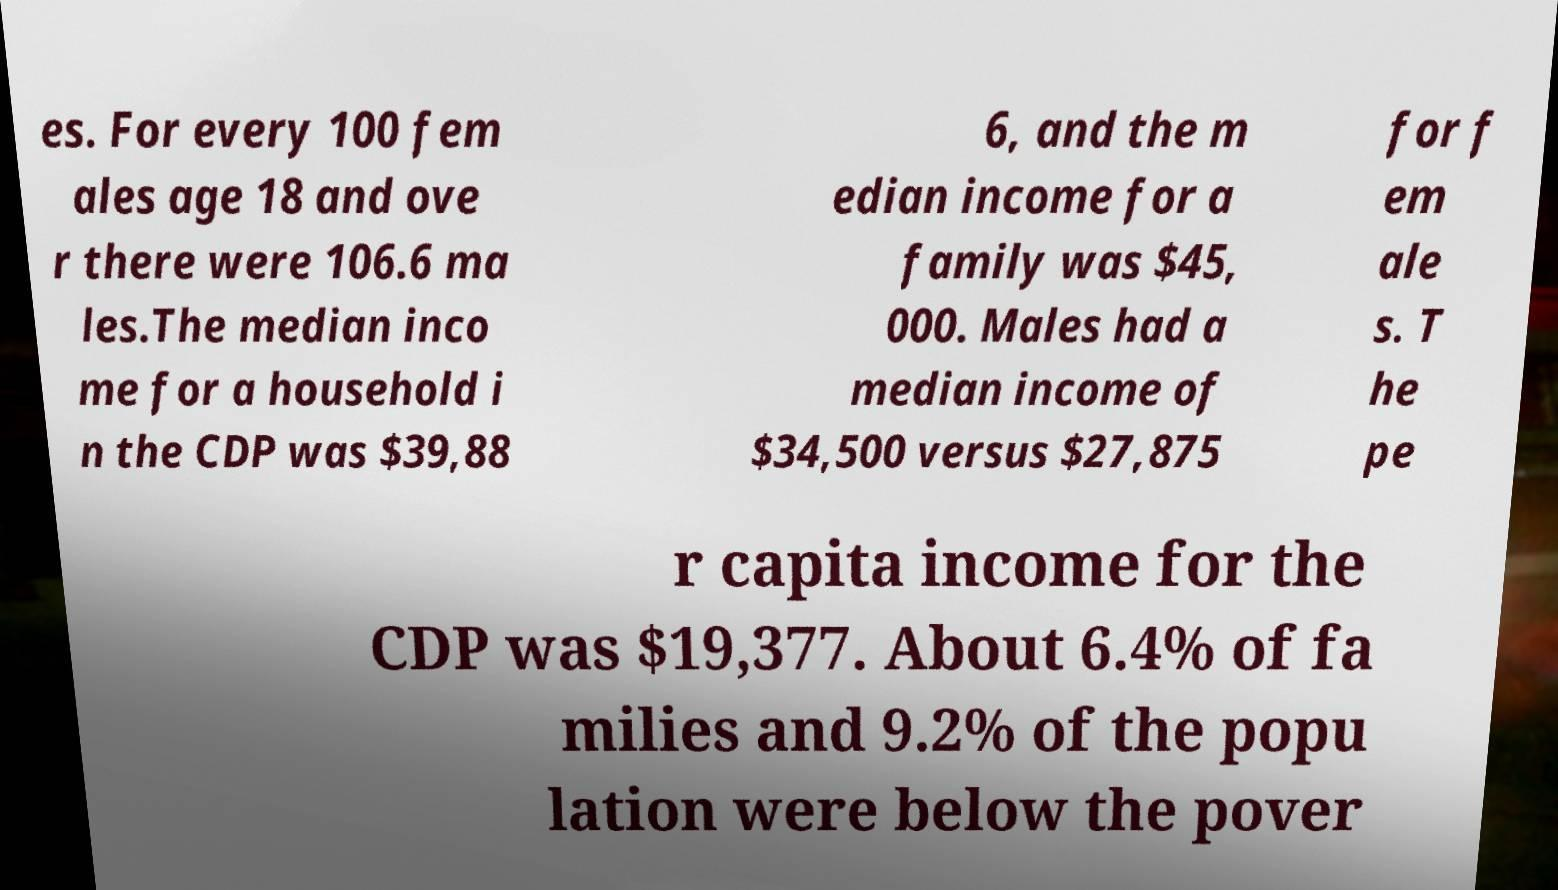For documentation purposes, I need the text within this image transcribed. Could you provide that? es. For every 100 fem ales age 18 and ove r there were 106.6 ma les.The median inco me for a household i n the CDP was $39,88 6, and the m edian income for a family was $45, 000. Males had a median income of $34,500 versus $27,875 for f em ale s. T he pe r capita income for the CDP was $19,377. About 6.4% of fa milies and 9.2% of the popu lation were below the pover 